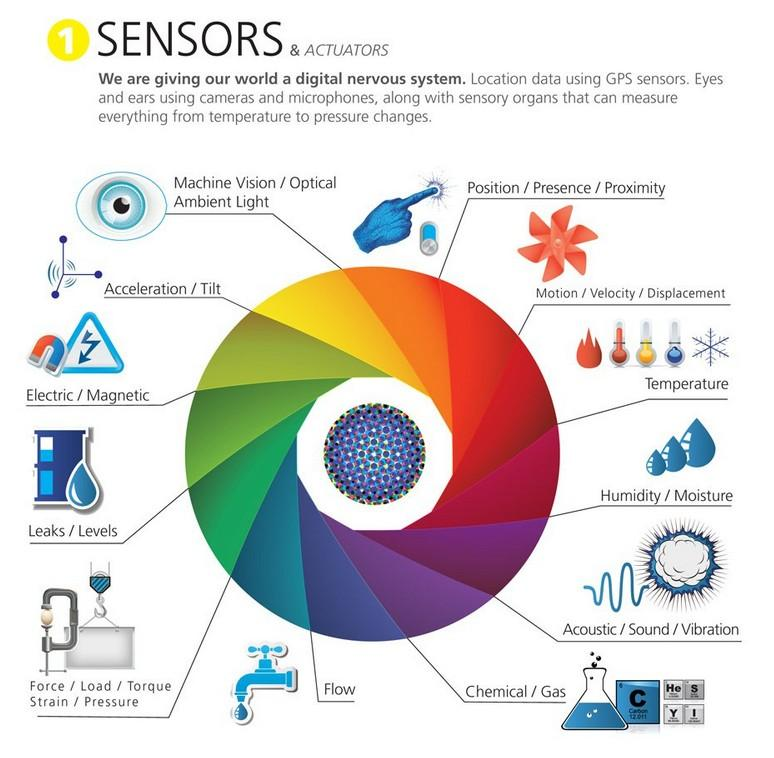Give some essential details in this illustration. The yellow region on the matrix shows the mapping of acceleration and tilt sensors, as well as machine vision and optical ambient light sensors. 